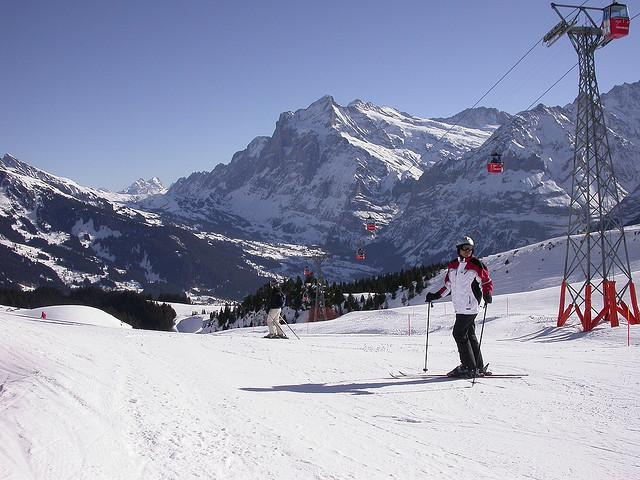Why are the bases of the towers brightly colored? Please explain your reasoning. safety visibility. Large metal towers have red towards the bottom and skiers are all around. 